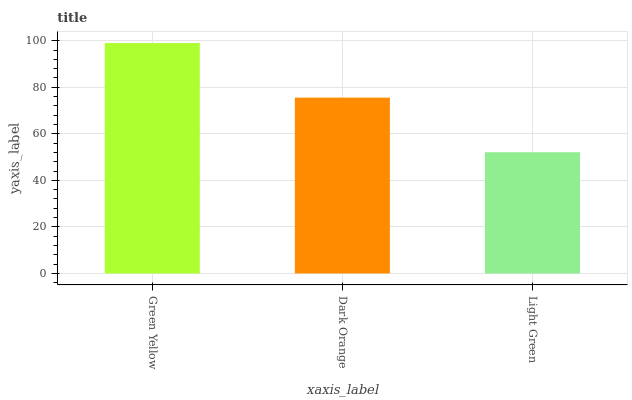Is Light Green the minimum?
Answer yes or no. Yes. Is Green Yellow the maximum?
Answer yes or no. Yes. Is Dark Orange the minimum?
Answer yes or no. No. Is Dark Orange the maximum?
Answer yes or no. No. Is Green Yellow greater than Dark Orange?
Answer yes or no. Yes. Is Dark Orange less than Green Yellow?
Answer yes or no. Yes. Is Dark Orange greater than Green Yellow?
Answer yes or no. No. Is Green Yellow less than Dark Orange?
Answer yes or no. No. Is Dark Orange the high median?
Answer yes or no. Yes. Is Dark Orange the low median?
Answer yes or no. Yes. Is Light Green the high median?
Answer yes or no. No. Is Green Yellow the low median?
Answer yes or no. No. 